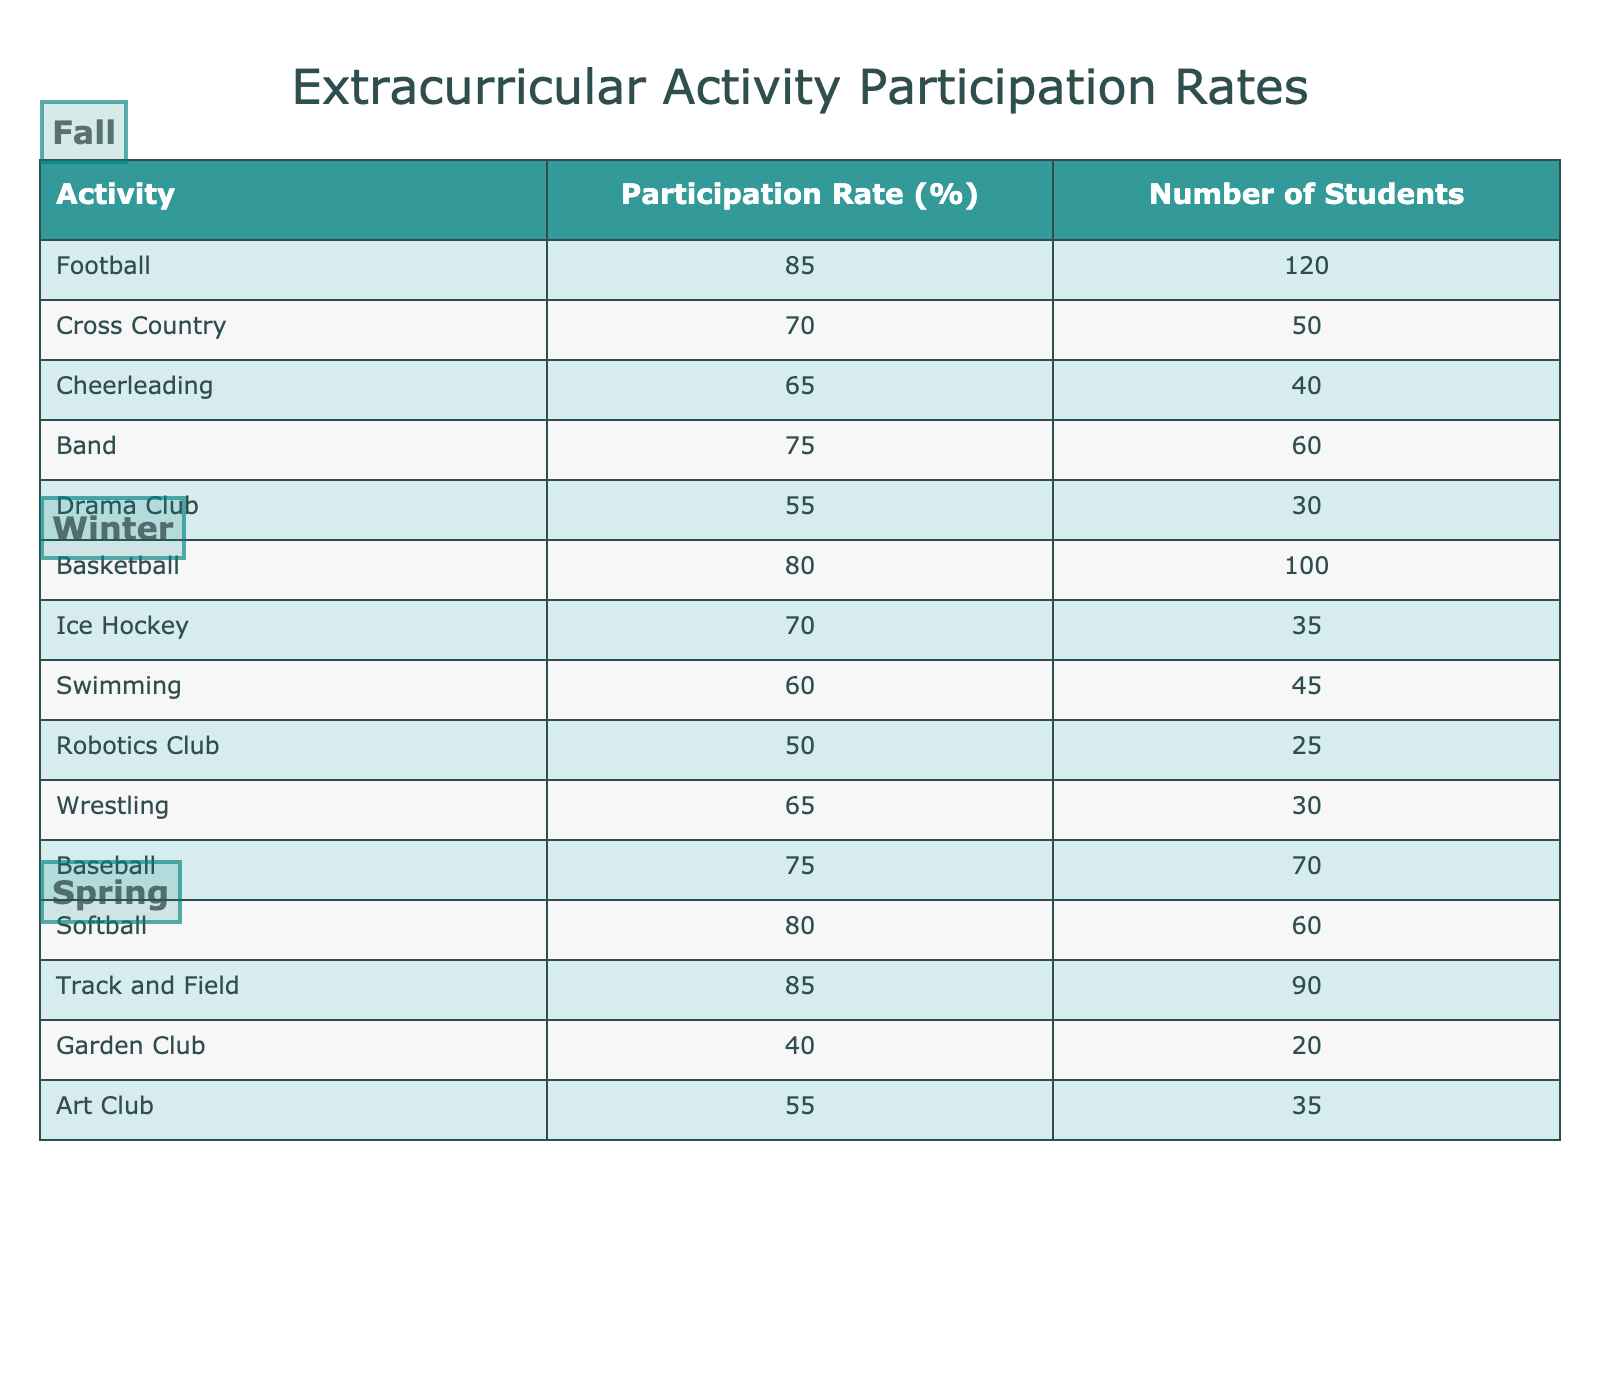What is the participation rate for the Drama Club in the Fall season? The table indicates the participation rate for each activity under the respective seasons. Looking under the Fall season, the Drama Club is listed with a participation rate of 55%.
Answer: 55% Which activity had the highest participation rate in Spring? By examining the Spring season activities listed in the table, Track and Field shows the highest participation rate at 85%, compared to other Spring activities listed.
Answer: Track and Field What is the average participation rate for all Winter activities? To find the average, add the participation rates of all Winter activities: Basketball (80) + Ice Hockey (70) + Swimming (60) + Robotics Club (50) + Wrestling (65) = 325. There are 5 activities, so divide 325 by 5 to find the average, which is 65.
Answer: 65% Is it true that more students participate in Softball than in Cross Country? Cross Country has 50 students participating, while Softball has 60 students. Since 60 is greater than 50, the statement is true.
Answer: Yes How many more students participated in Football compared to Wrestling? Football has 120 students while Wrestling has 30 students. To find the difference, subtract the number of Wrestling participants from the number of Football participants: 120 - 30 = 90.
Answer: 90 Which activity with the lowest participation rate has the highest number of students? The activity with the lowest participation rate is Garden Club with a 40% rate but has 20 students participating, while the next lowest, Robotics Club, has a 50% participation rate but 25 students. Therefore, Garden Club has the highest number of students among the lowest participation rates.
Answer: Garden Club What is the combined participation rate for all Fall activities? To find the combined participation rate, sum the participation rates of all Fall activities: 85 + 70 + 65 + 75 + 55 = 350. Divide the total by the number of activities (5) to find the average, which is 350/5 = 70.
Answer: 70 Which season has the most activities listed? The table shows that all seasons (Fall, Winter, Spring) have 5 activities each listed. Therefore, all seasons have an equal number of activities.
Answer: None, they are equal 